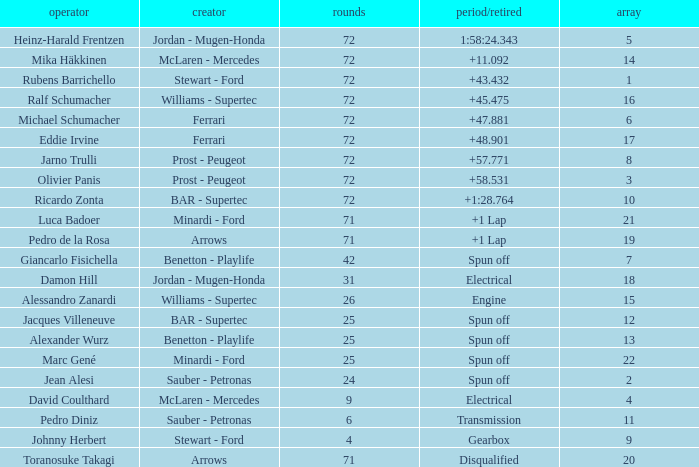How many laps did Ricardo Zonta drive with a grid less than 14? 72.0. Can you give me this table as a dict? {'header': ['operator', 'creator', 'rounds', 'period/retired', 'array'], 'rows': [['Heinz-Harald Frentzen', 'Jordan - Mugen-Honda', '72', '1:58:24.343', '5'], ['Mika Häkkinen', 'McLaren - Mercedes', '72', '+11.092', '14'], ['Rubens Barrichello', 'Stewart - Ford', '72', '+43.432', '1'], ['Ralf Schumacher', 'Williams - Supertec', '72', '+45.475', '16'], ['Michael Schumacher', 'Ferrari', '72', '+47.881', '6'], ['Eddie Irvine', 'Ferrari', '72', '+48.901', '17'], ['Jarno Trulli', 'Prost - Peugeot', '72', '+57.771', '8'], ['Olivier Panis', 'Prost - Peugeot', '72', '+58.531', '3'], ['Ricardo Zonta', 'BAR - Supertec', '72', '+1:28.764', '10'], ['Luca Badoer', 'Minardi - Ford', '71', '+1 Lap', '21'], ['Pedro de la Rosa', 'Arrows', '71', '+1 Lap', '19'], ['Giancarlo Fisichella', 'Benetton - Playlife', '42', 'Spun off', '7'], ['Damon Hill', 'Jordan - Mugen-Honda', '31', 'Electrical', '18'], ['Alessandro Zanardi', 'Williams - Supertec', '26', 'Engine', '15'], ['Jacques Villeneuve', 'BAR - Supertec', '25', 'Spun off', '12'], ['Alexander Wurz', 'Benetton - Playlife', '25', 'Spun off', '13'], ['Marc Gené', 'Minardi - Ford', '25', 'Spun off', '22'], ['Jean Alesi', 'Sauber - Petronas', '24', 'Spun off', '2'], ['David Coulthard', 'McLaren - Mercedes', '9', 'Electrical', '4'], ['Pedro Diniz', 'Sauber - Petronas', '6', 'Transmission', '11'], ['Johnny Herbert', 'Stewart - Ford', '4', 'Gearbox', '9'], ['Toranosuke Takagi', 'Arrows', '71', 'Disqualified', '20']]} 